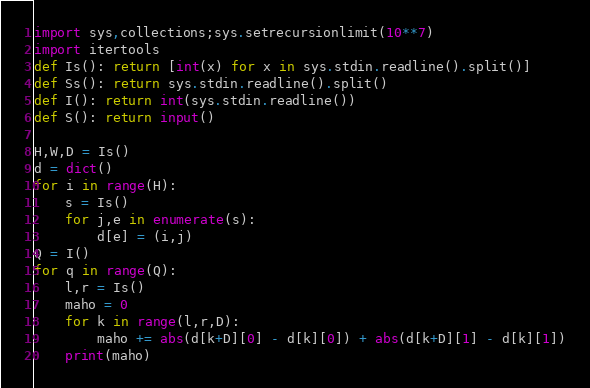Convert code to text. <code><loc_0><loc_0><loc_500><loc_500><_Python_>import sys,collections;sys.setrecursionlimit(10**7)
import itertools
def Is(): return [int(x) for x in sys.stdin.readline().split()]
def Ss(): return sys.stdin.readline().split()
def I(): return int(sys.stdin.readline())
def S(): return input()

H,W,D = Is()
d = dict()
for i in range(H):
    s = Is()
    for j,e in enumerate(s):
        d[e] = (i,j)
Q = I()
for q in range(Q):
    l,r = Is()
    maho = 0
    for k in range(l,r,D):
        maho += abs(d[k+D][0] - d[k][0]) + abs(d[k+D][1] - d[k][1])
    print(maho)</code> 